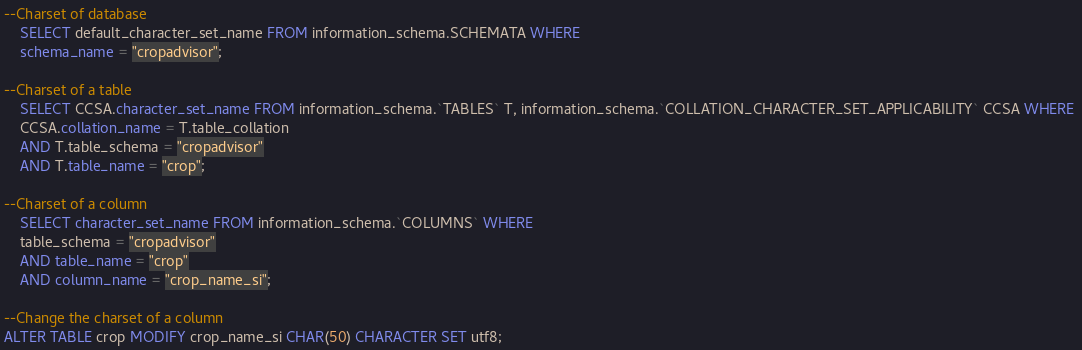<code> <loc_0><loc_0><loc_500><loc_500><_SQL_>--Charset of database
	SELECT default_character_set_name FROM information_schema.SCHEMATA WHERE 
	schema_name = "cropadvisor";

--Charset of a table
	SELECT CCSA.character_set_name FROM information_schema.`TABLES` T, information_schema.`COLLATION_CHARACTER_SET_APPLICABILITY` CCSA WHERE 
	CCSA.collation_name = T.table_collation 
	AND T.table_schema = "cropadvisor" 
	AND T.table_name = "crop";

--Charset of a column
	SELECT character_set_name FROM information_schema.`COLUMNS` WHERE 
	table_schema = "cropadvisor" 
	AND table_name = "crop" 
	AND column_name = "crop_name_si";

--Change the charset of a column
ALTER TABLE crop MODIFY crop_name_si CHAR(50) CHARACTER SET utf8;</code> 